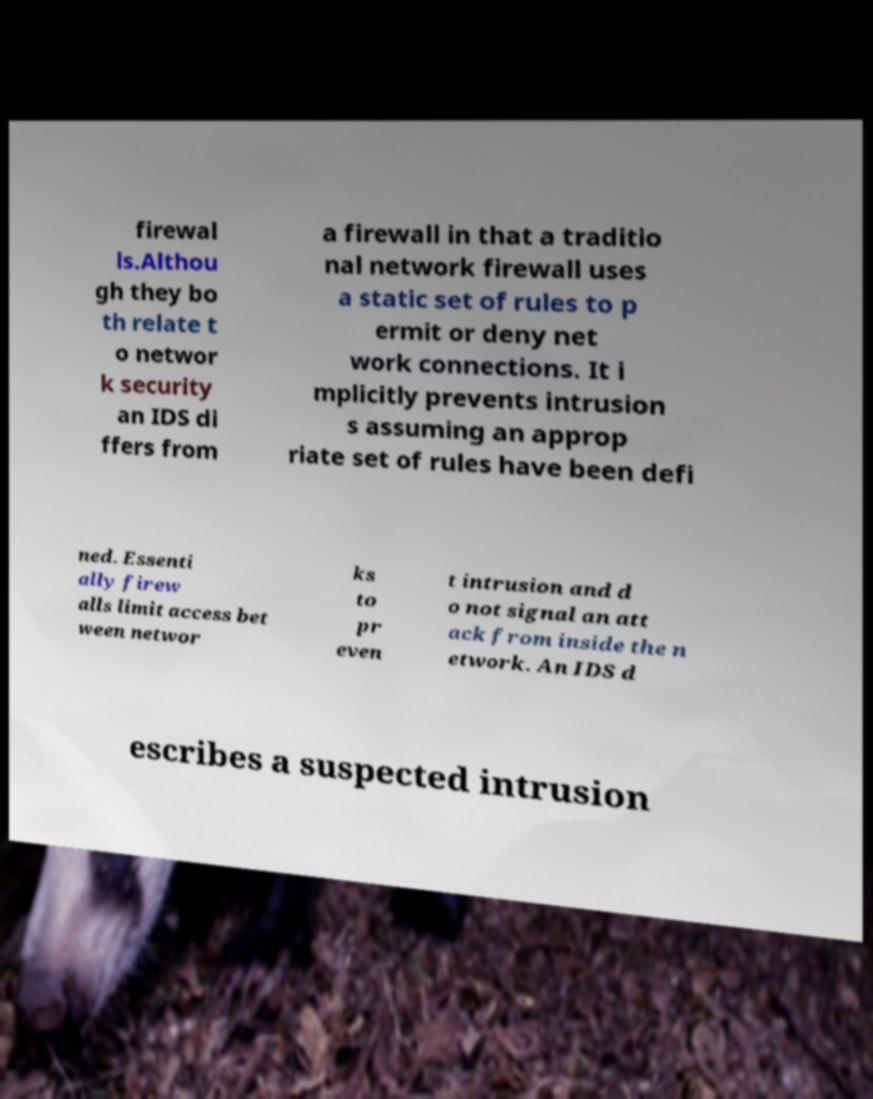Please identify and transcribe the text found in this image. firewal ls.Althou gh they bo th relate t o networ k security an IDS di ffers from a firewall in that a traditio nal network firewall uses a static set of rules to p ermit or deny net work connections. It i mplicitly prevents intrusion s assuming an approp riate set of rules have been defi ned. Essenti ally firew alls limit access bet ween networ ks to pr even t intrusion and d o not signal an att ack from inside the n etwork. An IDS d escribes a suspected intrusion 